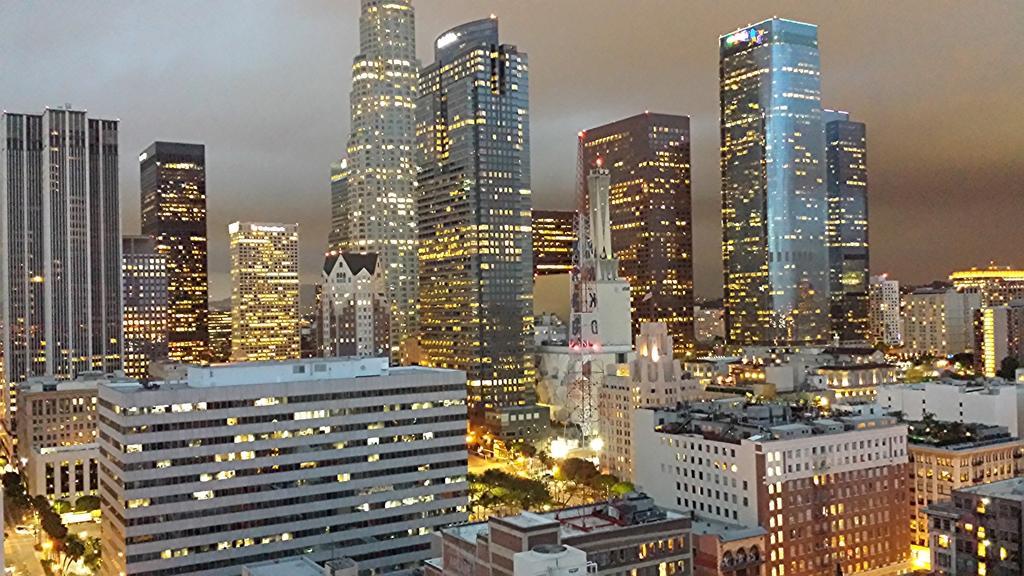Could you give a brief overview of what you see in this image? In this image we can see buildings, tower, road, trees. In the background there is sky. 